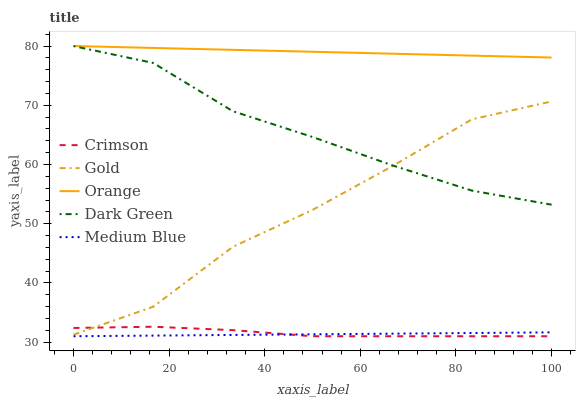Does Medium Blue have the minimum area under the curve?
Answer yes or no. Yes. Does Orange have the maximum area under the curve?
Answer yes or no. Yes. Does Orange have the minimum area under the curve?
Answer yes or no. No. Does Medium Blue have the maximum area under the curve?
Answer yes or no. No. Is Medium Blue the smoothest?
Answer yes or no. Yes. Is Gold the roughest?
Answer yes or no. Yes. Is Orange the smoothest?
Answer yes or no. No. Is Orange the roughest?
Answer yes or no. No. Does Crimson have the lowest value?
Answer yes or no. Yes. Does Orange have the lowest value?
Answer yes or no. No. Does Orange have the highest value?
Answer yes or no. Yes. Does Medium Blue have the highest value?
Answer yes or no. No. Is Medium Blue less than Gold?
Answer yes or no. Yes. Is Dark Green greater than Crimson?
Answer yes or no. Yes. Does Gold intersect Crimson?
Answer yes or no. Yes. Is Gold less than Crimson?
Answer yes or no. No. Is Gold greater than Crimson?
Answer yes or no. No. Does Medium Blue intersect Gold?
Answer yes or no. No. 